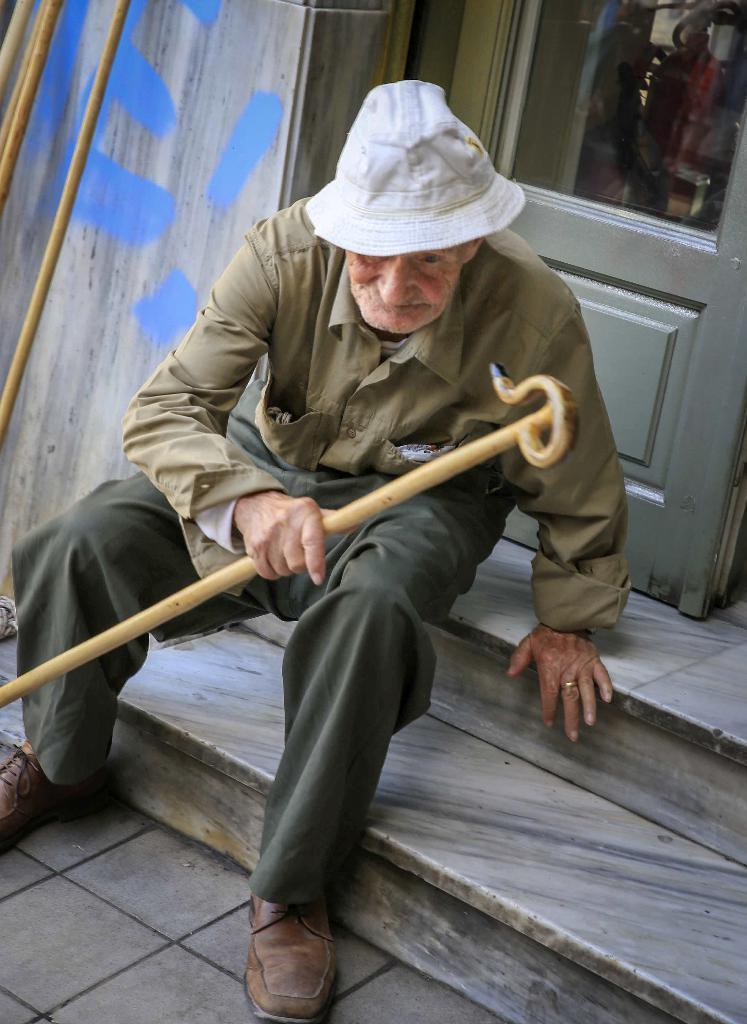In one or two sentences, can you explain what this image depicts? There is a person wearing hat is holding a walking stick and sitting on the steps. In the back there is a door with a glass panel. Also there is a wall and sticks. 